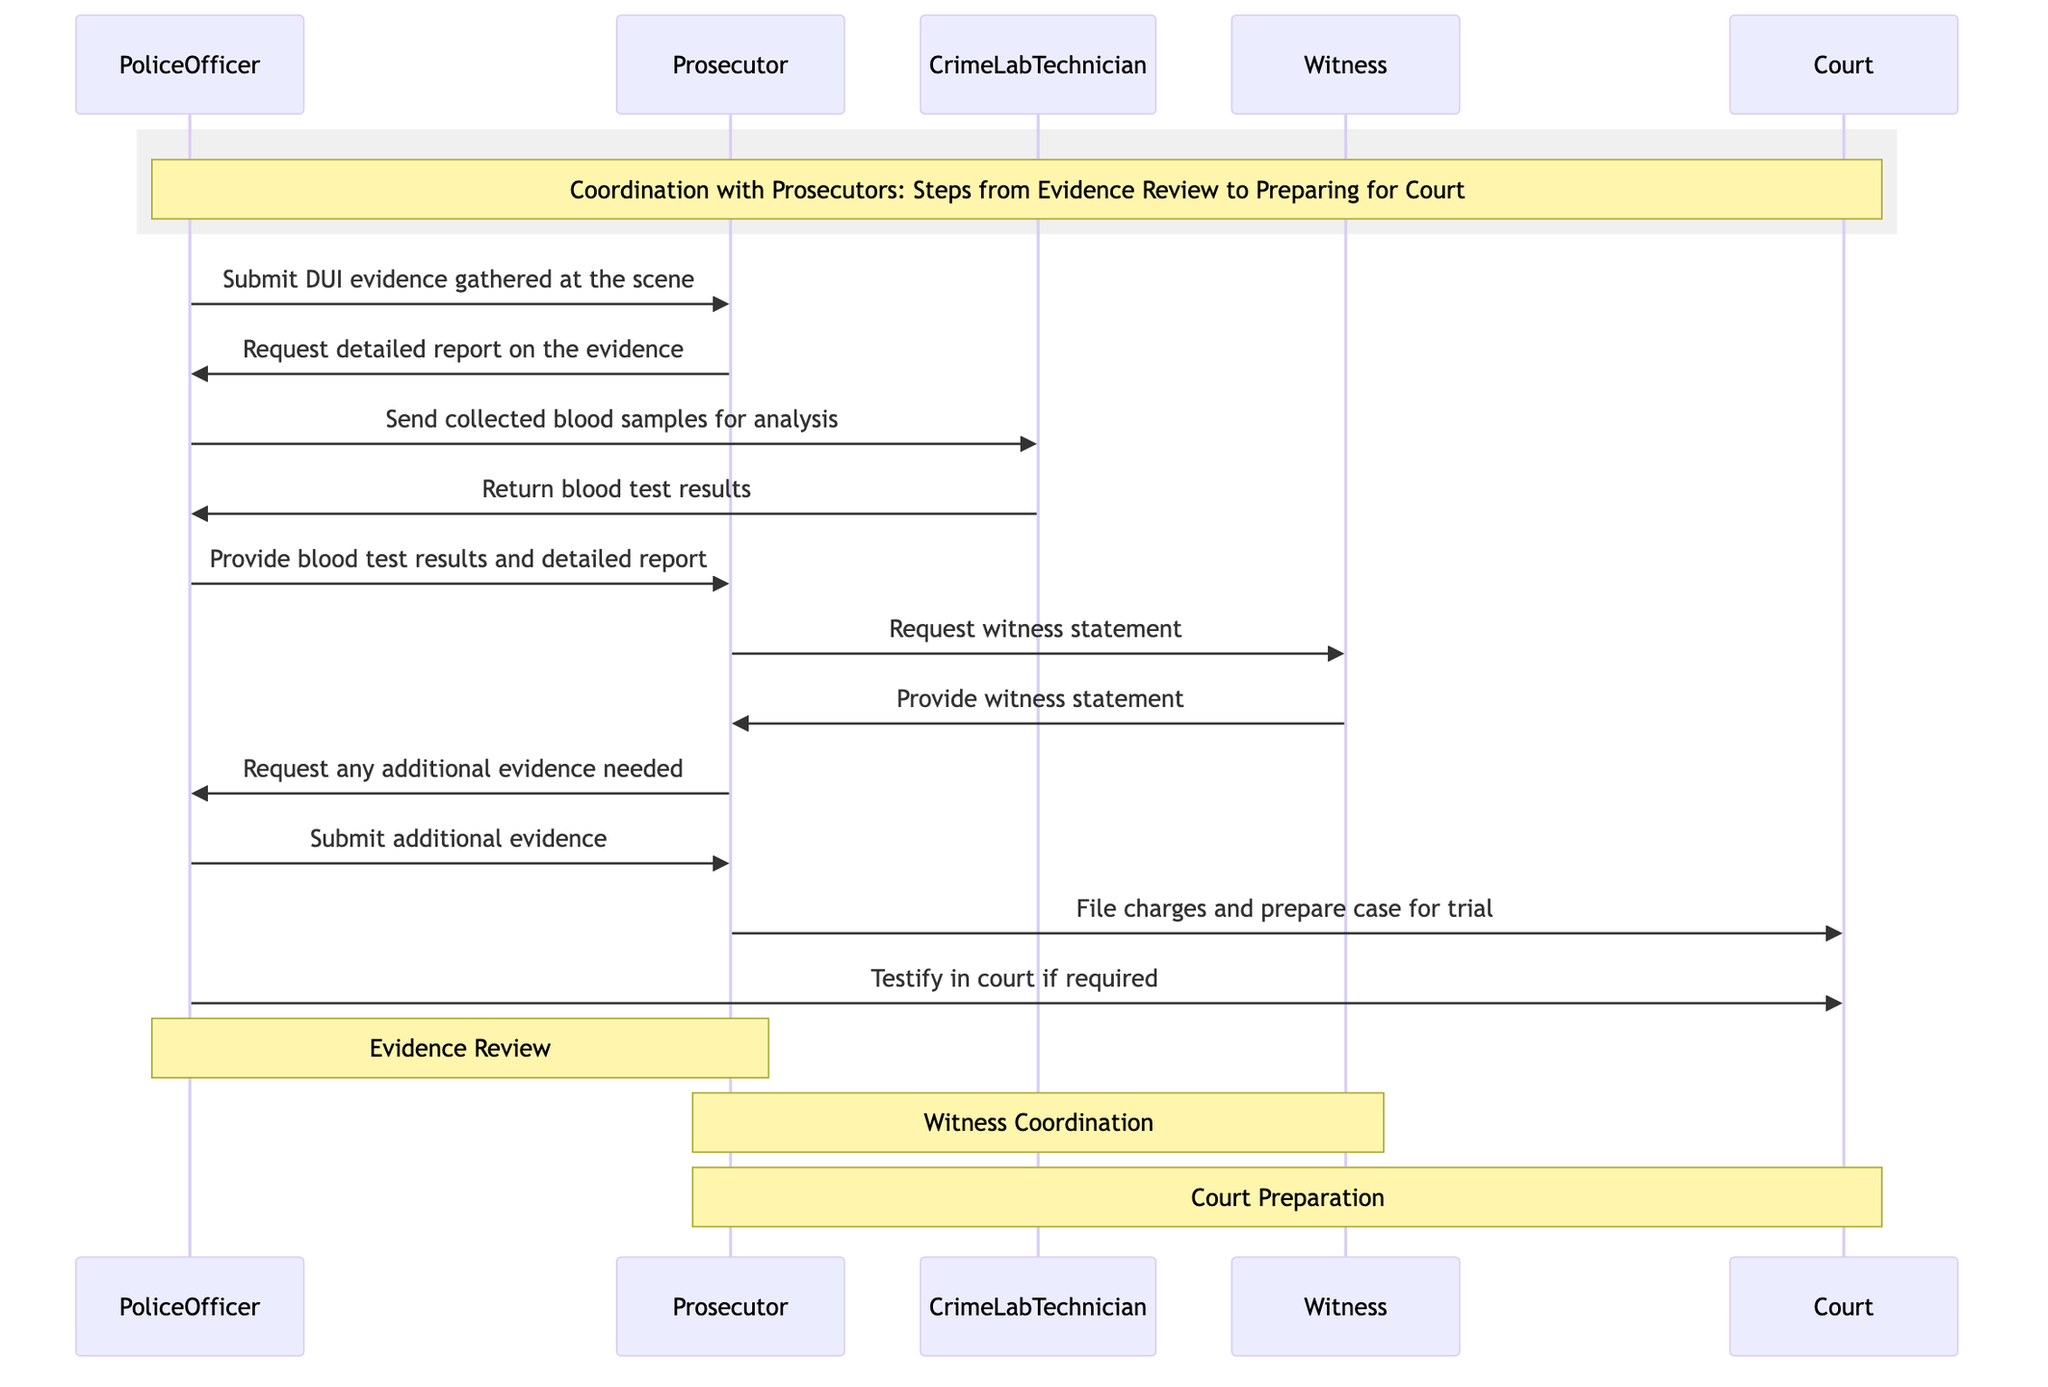What is the first message sent in the diagram? The first message sent in the diagram is from the PoliceOfficer to the Prosecutor, specifically stating "Submit DUI evidence gathered at the scene."
Answer: Submit DUI evidence gathered at the scene How many participants are in the diagram? The diagram lists a total of five participants: PoliceOfficer, Prosecutor, CrimeLabTechnician, Witness, and Court.
Answer: 5 Which participant sends blood test results back to the PoliceOfficer? The CrimeLabTechnician sends blood test results back to the PoliceOfficer following the submission of blood samples.
Answer: CrimeLabTechnician What is the last action taken by the PoliceOfficer in the sequence? The last action taken by the PoliceOfficer is to "Testify in court if required." This comes after the Prosecutor has filed charges and prepared the case for trial.
Answer: Testify in court if required How many messages are exchanged between the Prosecutor and the PoliceOfficer? There are a total of four messages exchanged between the Prosecutor and the PoliceOfficer throughout the sequence. These messages involve submission of evidence, a request for a detailed report, provision of blood test results, and submission of additional evidence.
Answer: 4 What does the Prosecutor request from the Witness? The Prosecutor requests a witness statement from the Witness, which is necessary for building the case.
Answer: Request witness statement What is the main purpose of the messages exchanged between the Prosecutor and Witness? The main purpose of the messages exchanged between the Prosecutor and Witness is to gather necessary witness statements that contribute to building the case for the trial.
Answer: Witness coordination Which participant prepares the case for trial? The Prosecutor is the participant responsible for preparing the case for trial by filing charges and organizing all gathered evidence and statements.
Answer: Prosecutor 